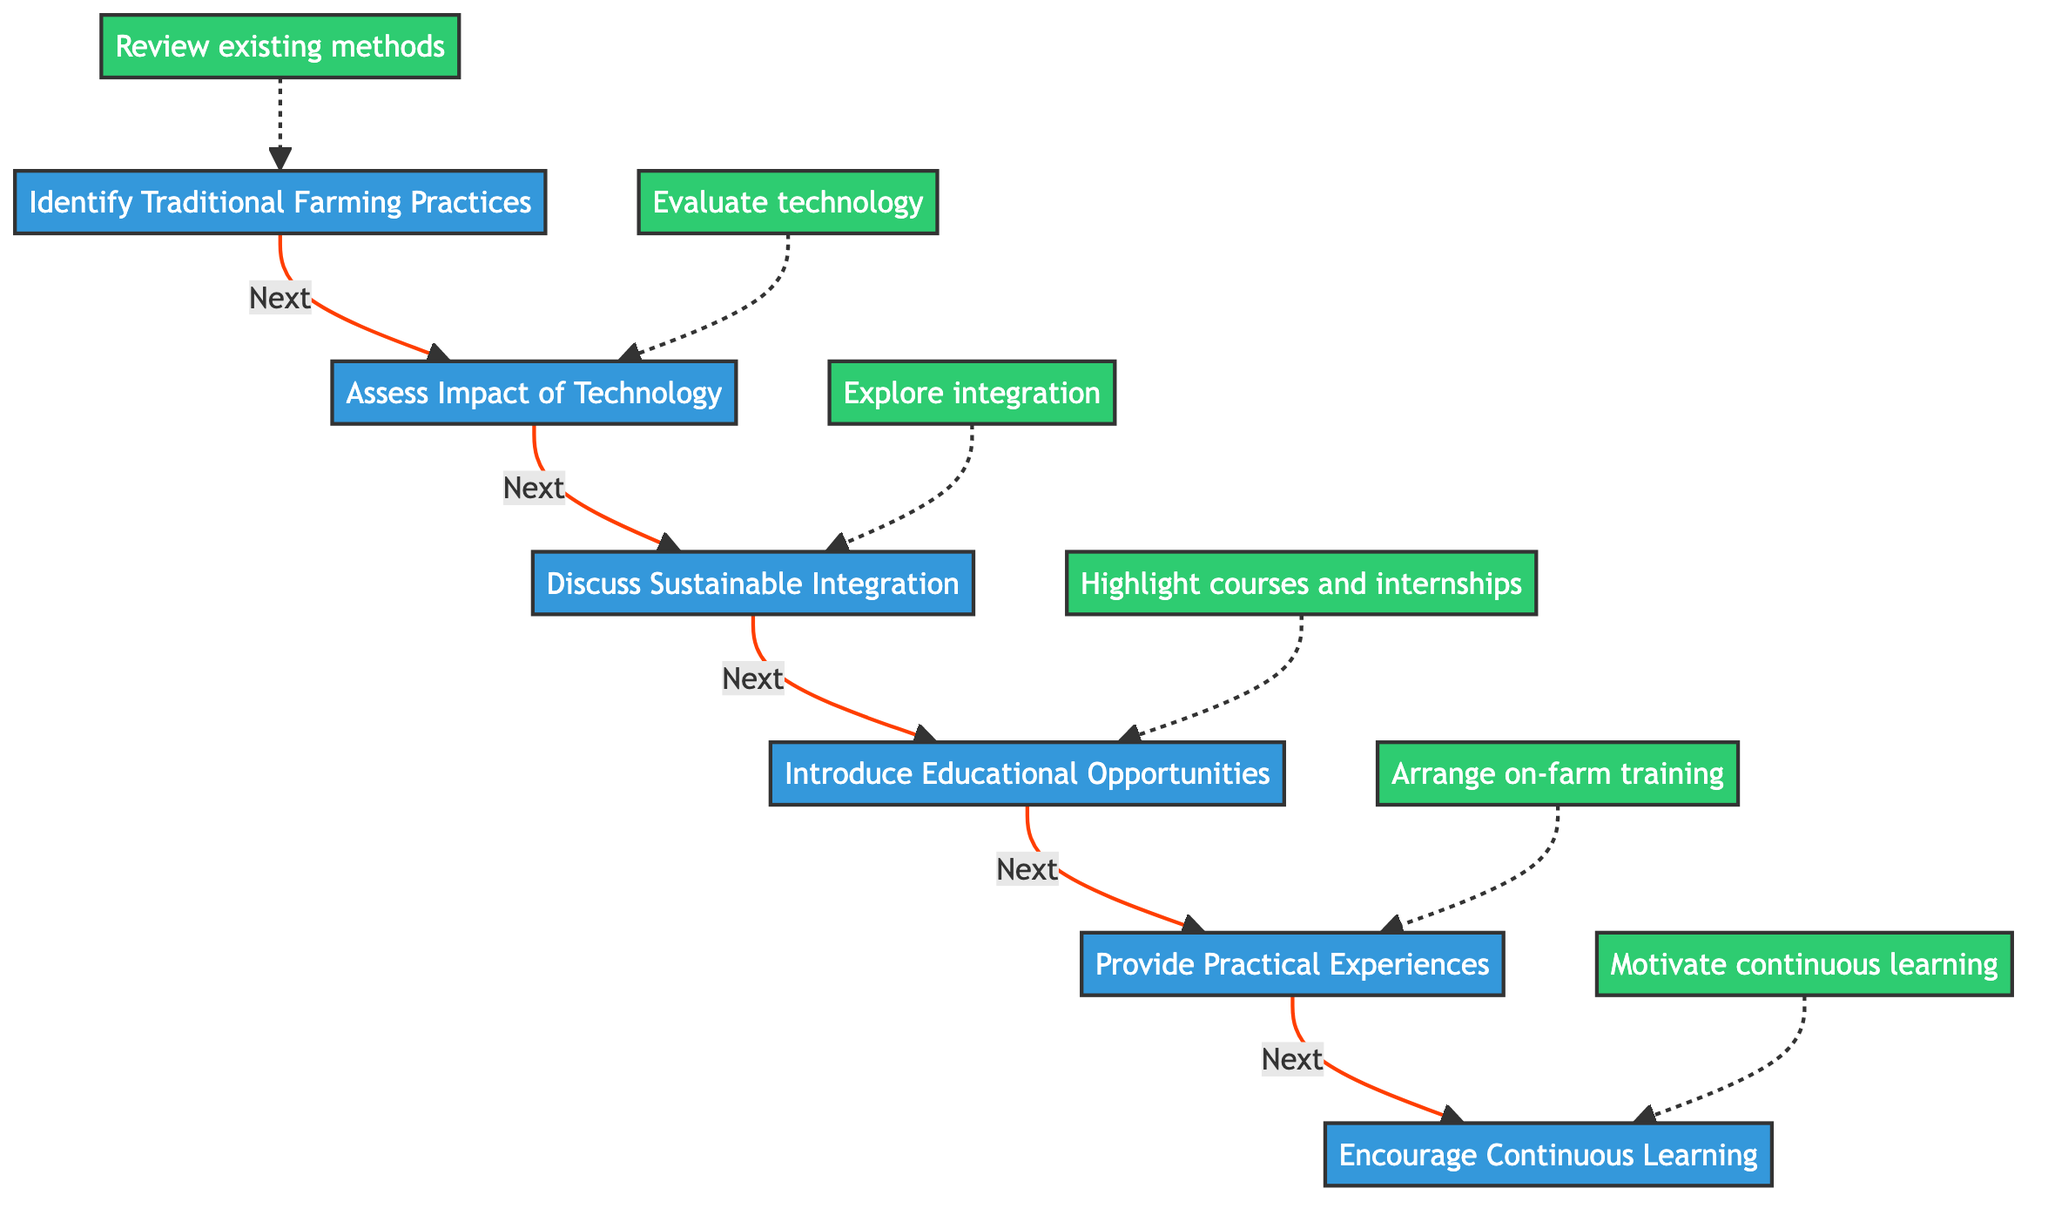What is the first step in the diagram? The first step is identified as "Identify Traditional Farming Practices," which is the starting node of the flowchart representing the initial action to be taken.
Answer: Identify Traditional Farming Practices How many steps are there in total? Counting each node in the diagram, there are a total of six steps represented as nodes from the start to the end of the flowchart.
Answer: Six What is the last step in the process? The last step in the diagram is "Encourage Continuous Learning," which signifies the final action in the flow of steps presented in the flowchart.
Answer: Encourage Continuous Learning Which step discusses the integration of technology? The step that focuses on the integration of technology is "Discuss Sustainable Integration," as it explores how to incorporate technology while preserving traditional practices.
Answer: Discuss Sustainable Integration How are "Provide Practical Experiences" and "Encourage Continuous Learning" related? "Provide Practical Experiences" is a preceding step that aims to offer hands-on training and exposure before "Encourage Continuous Learning," which encourages ongoing education about agriculture advancements.
Answer: Sequential relationship What is the detailed aspect of "Assess Impact of Technology"? "Assess Impact of Technology" evaluates tools such as GPS-guided tractors and automated irrigation, which informs the farmers about the technological advancements to consider.
Answer: Evaluate technology like GPS-guided tractors Which step highlights courses and internships? The step that highlights courses and internships is "Introduce Educational Opportunities," where different educational paths in agricultural science are presented.
Answer: Introduce Educational Opportunities What is the primary goal of the "Discuss Sustainable Integration" step? The primary goal of this step is to explore how to incorporate advanced technology while upholding traditional values and practices, achieving a balance between old and new methods.
Answer: Incorporate technology while maintaining values Which two steps are most closely related in the flow? "Provide Practical Experiences" and "Encourage Continuous Learning" are closely related, as providing training leads directly into the encouragement for ongoing education about agricultural practices and technologies.
Answer: Provide Practical Experiences and Encourage Continuous Learning 